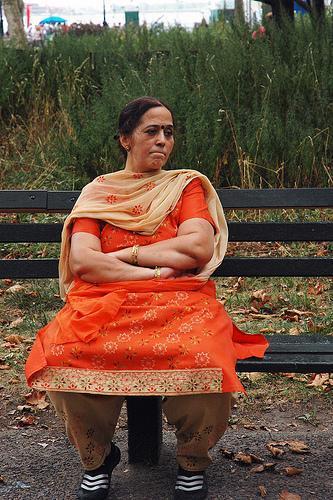How many boards are in the back of the bench?
Give a very brief answer. 3. How many women on the bench?
Give a very brief answer. 1. 